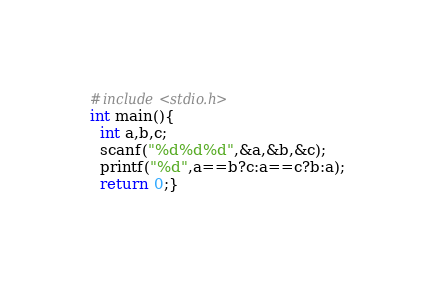<code> <loc_0><loc_0><loc_500><loc_500><_C_>#include<stdio.h>
int main(){
  int a,b,c;
  scanf("%d%d%d",&a,&b,&c);
  printf("%d",a==b?c:a==c?b:a);
  return 0;}</code> 